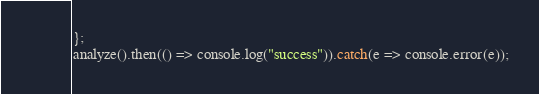Convert code to text. <code><loc_0><loc_0><loc_500><loc_500><_JavaScript_>
};
analyze().then(() => console.log("success")).catch(e => console.error(e));
</code> 